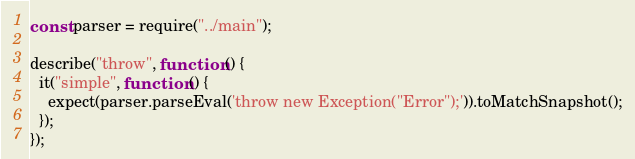<code> <loc_0><loc_0><loc_500><loc_500><_JavaScript_>const parser = require("../main");

describe("throw", function () {
  it("simple", function () {
    expect(parser.parseEval('throw new Exception("Error");')).toMatchSnapshot();
  });
});
</code> 